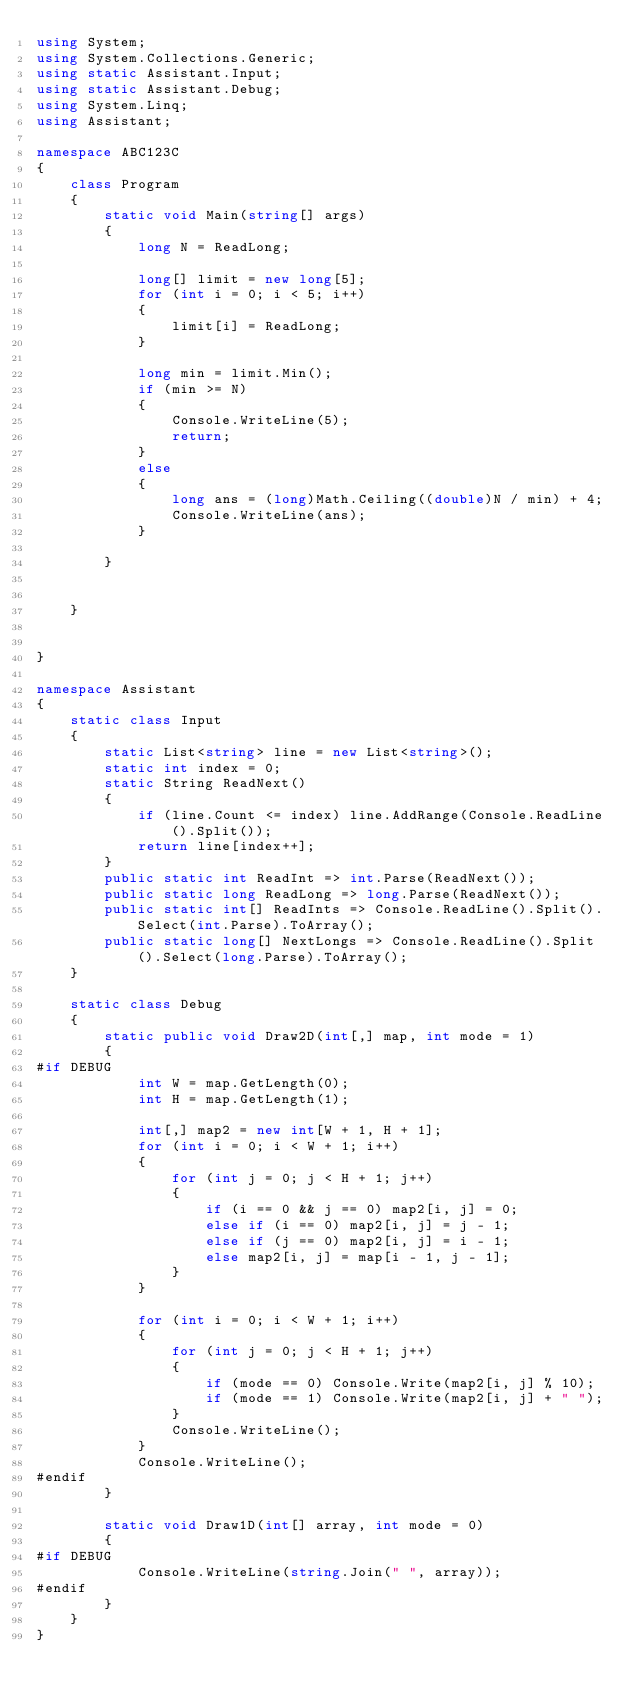Convert code to text. <code><loc_0><loc_0><loc_500><loc_500><_C#_>using System;
using System.Collections.Generic;
using static Assistant.Input;
using static Assistant.Debug;
using System.Linq;
using Assistant;

namespace ABC123C
{
    class Program
    {
        static void Main(string[] args)
        {
            long N = ReadLong;

            long[] limit = new long[5];
            for (int i = 0; i < 5; i++)
            {
                limit[i] = ReadLong;
            }

            long min = limit.Min();
            if (min >= N)
            {
                Console.WriteLine(5);
                return;
            }
            else
            {
                long ans = (long)Math.Ceiling((double)N / min) + 4;
                Console.WriteLine(ans);
            }

        }
        

    }


}

namespace Assistant
{
    static class Input
    {
        static List<string> line = new List<string>();
        static int index = 0;
        static String ReadNext()
        {
            if (line.Count <= index) line.AddRange(Console.ReadLine().Split());
            return line[index++];
        }
        public static int ReadInt => int.Parse(ReadNext());
        public static long ReadLong => long.Parse(ReadNext());
        public static int[] ReadInts => Console.ReadLine().Split().Select(int.Parse).ToArray();
        public static long[] NextLongs => Console.ReadLine().Split().Select(long.Parse).ToArray();
    }

    static class Debug
    {
        static public void Draw2D(int[,] map, int mode = 1)
        {
#if DEBUG
            int W = map.GetLength(0);
            int H = map.GetLength(1);

            int[,] map2 = new int[W + 1, H + 1];
            for (int i = 0; i < W + 1; i++)
            {
                for (int j = 0; j < H + 1; j++)
                {
                    if (i == 0 && j == 0) map2[i, j] = 0;
                    else if (i == 0) map2[i, j] = j - 1;
                    else if (j == 0) map2[i, j] = i - 1;
                    else map2[i, j] = map[i - 1, j - 1];
                }
            }

            for (int i = 0; i < W + 1; i++)
            {
                for (int j = 0; j < H + 1; j++)
                {
                    if (mode == 0) Console.Write(map2[i, j] % 10);
                    if (mode == 1) Console.Write(map2[i, j] + " ");
                }
                Console.WriteLine();
            }
            Console.WriteLine();
#endif
        }

        static void Draw1D(int[] array, int mode = 0)
        {
#if DEBUG
            Console.WriteLine(string.Join(" ", array));
#endif
        }
    }
}
</code> 